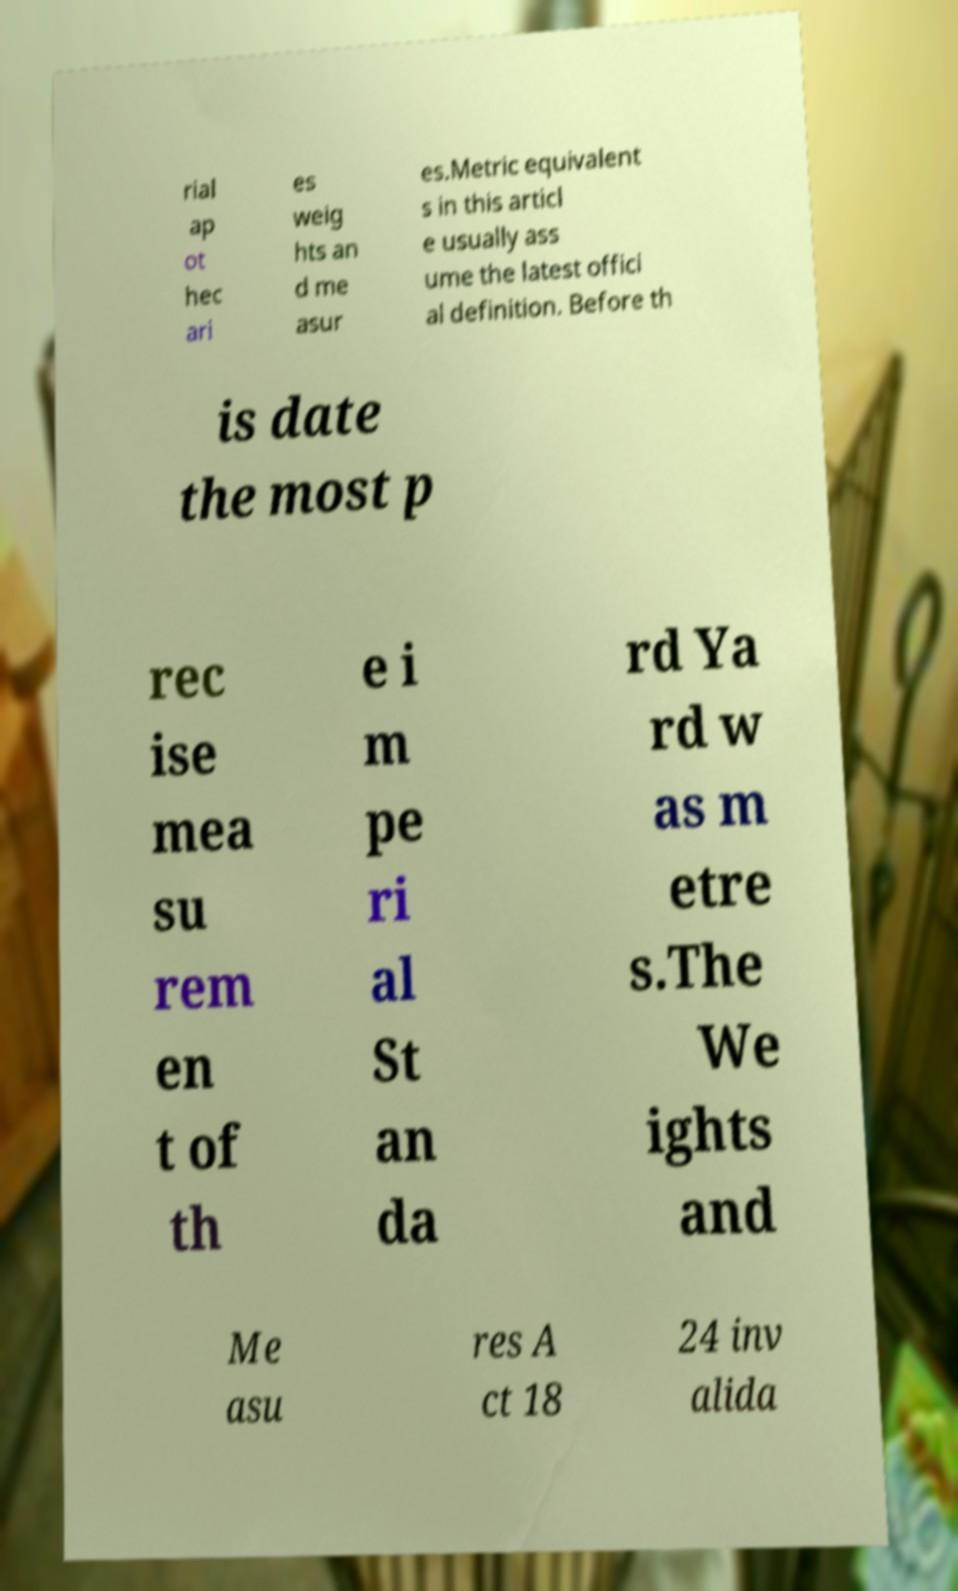Can you read and provide the text displayed in the image?This photo seems to have some interesting text. Can you extract and type it out for me? rial ap ot hec ari es weig hts an d me asur es.Metric equivalent s in this articl e usually ass ume the latest offici al definition. Before th is date the most p rec ise mea su rem en t of th e i m pe ri al St an da rd Ya rd w as m etre s.The We ights and Me asu res A ct 18 24 inv alida 